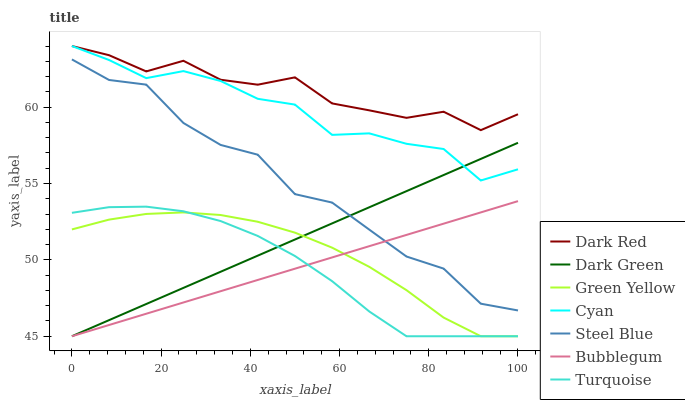Does Bubblegum have the minimum area under the curve?
Answer yes or no. Yes. Does Dark Red have the maximum area under the curve?
Answer yes or no. Yes. Does Steel Blue have the minimum area under the curve?
Answer yes or no. No. Does Steel Blue have the maximum area under the curve?
Answer yes or no. No. Is Dark Green the smoothest?
Answer yes or no. Yes. Is Steel Blue the roughest?
Answer yes or no. Yes. Is Dark Red the smoothest?
Answer yes or no. No. Is Dark Red the roughest?
Answer yes or no. No. Does Steel Blue have the lowest value?
Answer yes or no. No. Does Cyan have the highest value?
Answer yes or no. Yes. Does Steel Blue have the highest value?
Answer yes or no. No. Is Green Yellow less than Cyan?
Answer yes or no. Yes. Is Cyan greater than Steel Blue?
Answer yes or no. Yes. Does Green Yellow intersect Cyan?
Answer yes or no. No. 